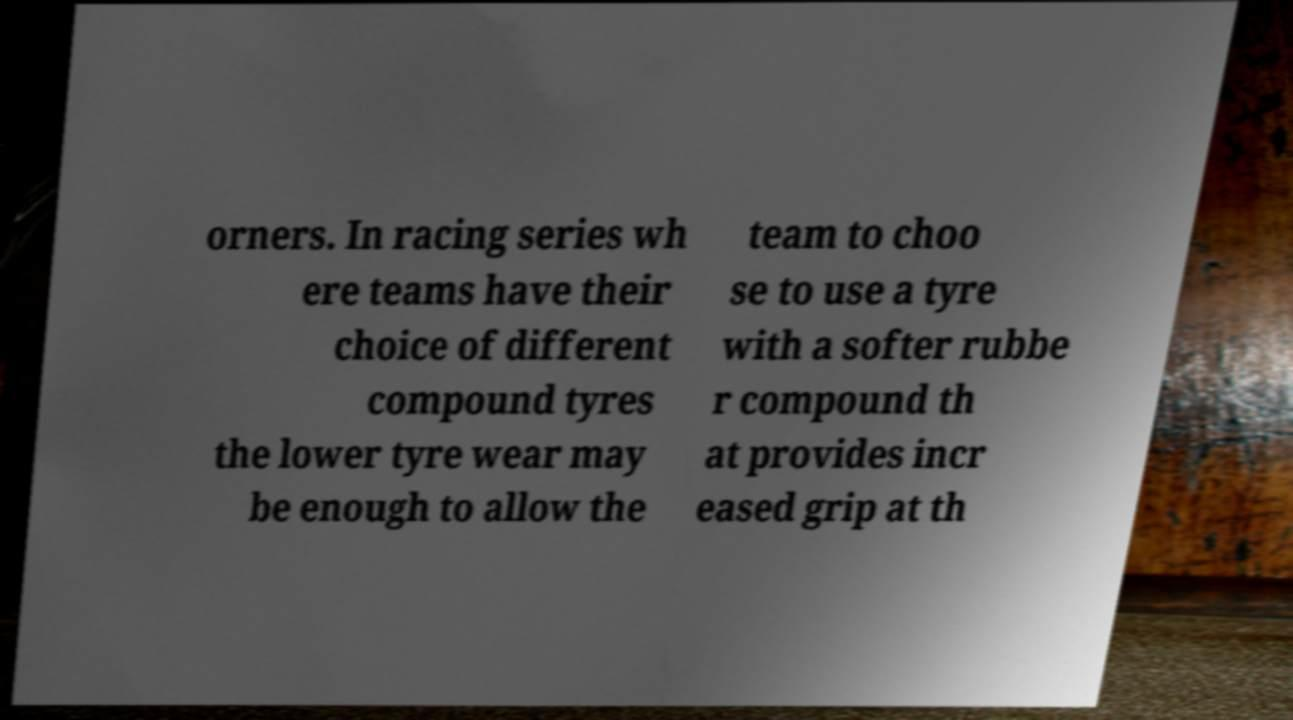Can you read and provide the text displayed in the image?This photo seems to have some interesting text. Can you extract and type it out for me? orners. In racing series wh ere teams have their choice of different compound tyres the lower tyre wear may be enough to allow the team to choo se to use a tyre with a softer rubbe r compound th at provides incr eased grip at th 